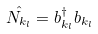Convert formula to latex. <formula><loc_0><loc_0><loc_500><loc_500>\hat { N _ { k _ { l } } } = b _ { k _ { l } } ^ { \dagger } b _ { k _ { l } }</formula> 